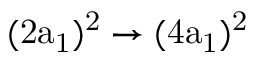<formula> <loc_0><loc_0><loc_500><loc_500>( 2 a _ { 1 } ) ^ { 2 } \rightarrow ( 4 a _ { 1 } ) ^ { 2 }</formula> 